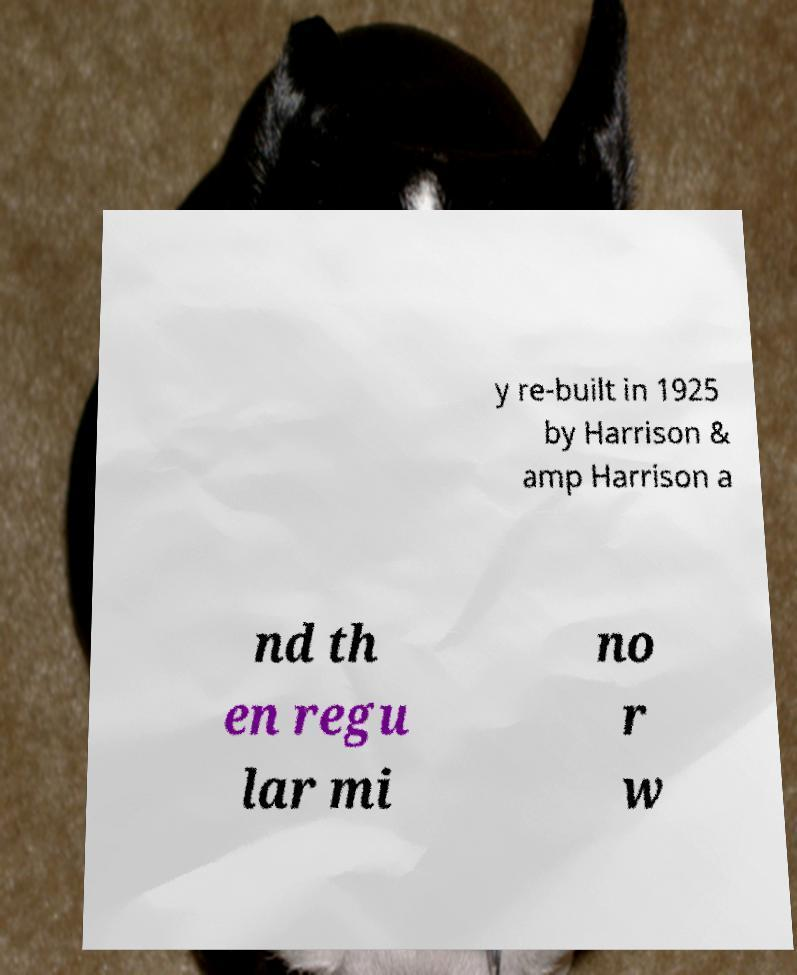Please read and relay the text visible in this image. What does it say? y re-built in 1925 by Harrison & amp Harrison a nd th en regu lar mi no r w 